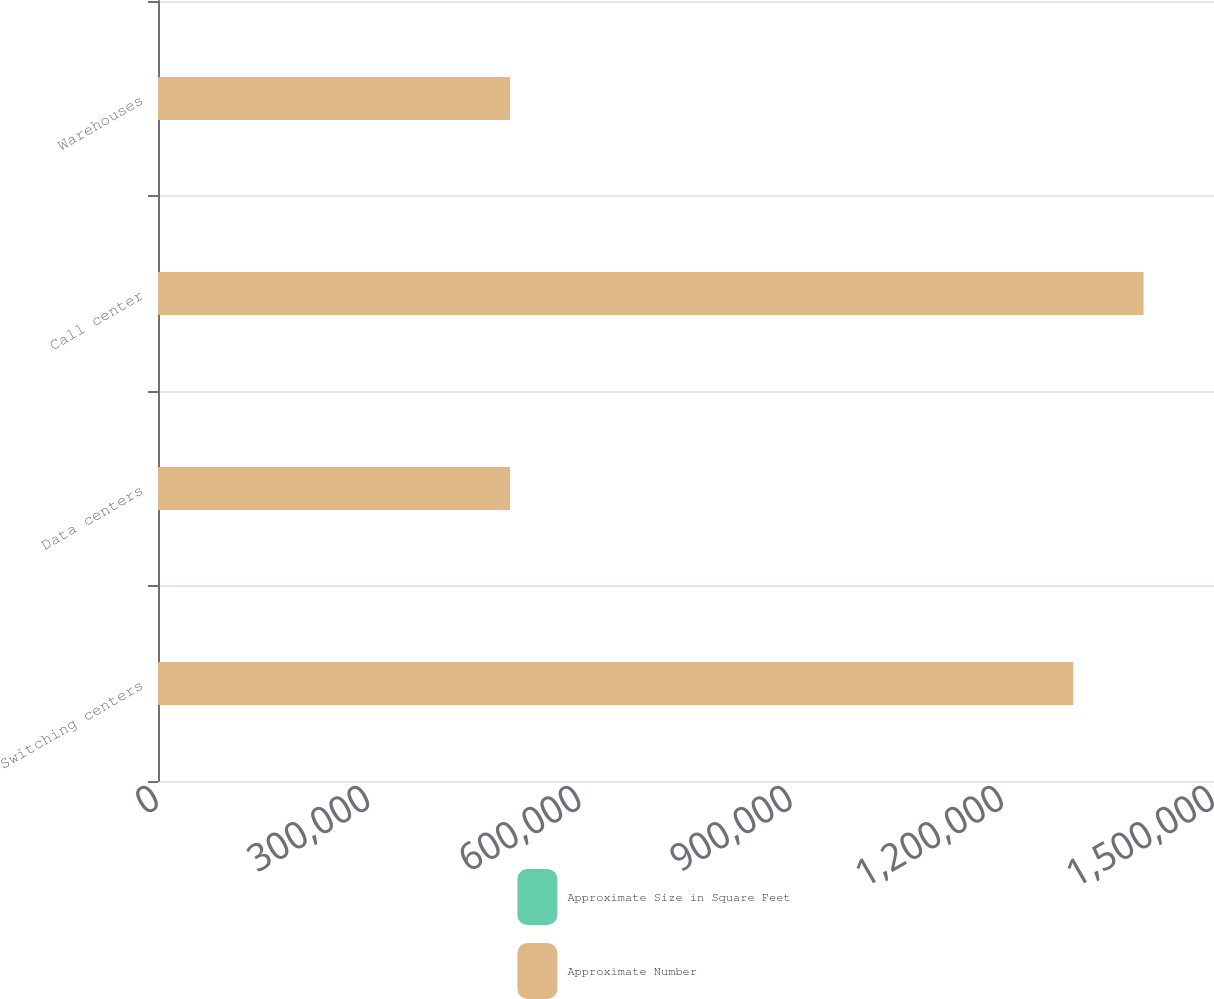Convert chart to OTSL. <chart><loc_0><loc_0><loc_500><loc_500><stacked_bar_chart><ecel><fcel>Switching centers<fcel>Data centers<fcel>Call center<fcel>Warehouses<nl><fcel>Approximate Size in Square Feet<fcel>61<fcel>6<fcel>17<fcel>15<nl><fcel>Approximate Number<fcel>1.3e+06<fcel>500000<fcel>1.4e+06<fcel>500000<nl></chart> 